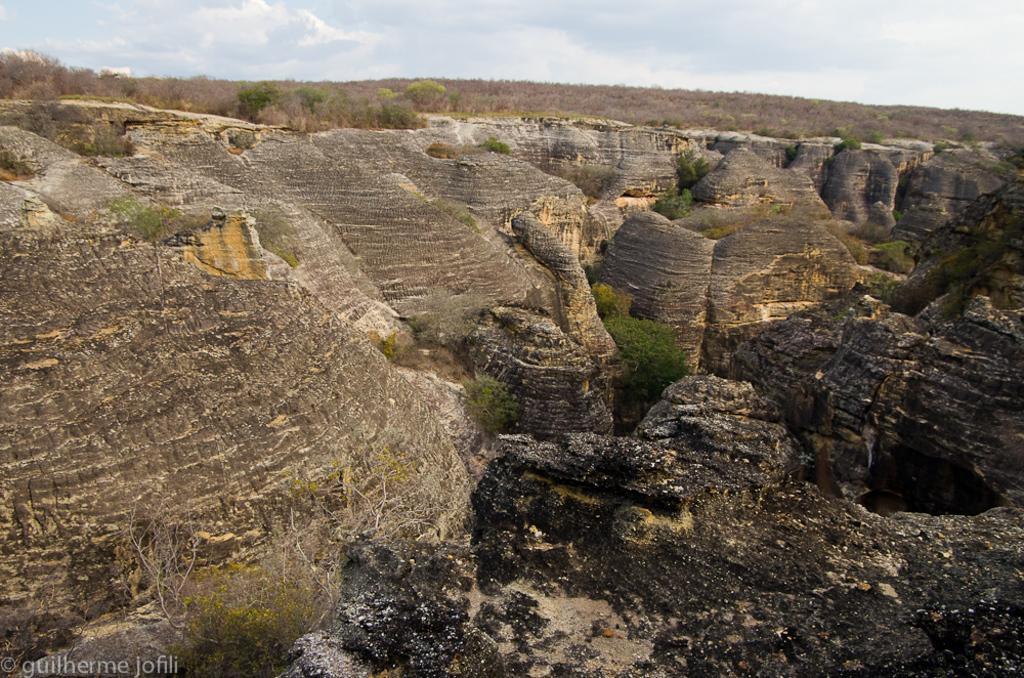Please provide a concise description of this image. In this image I can see mountains with some trees and grass. At the top of the image I can see the sky and in the left bottom corner I can see some text. 